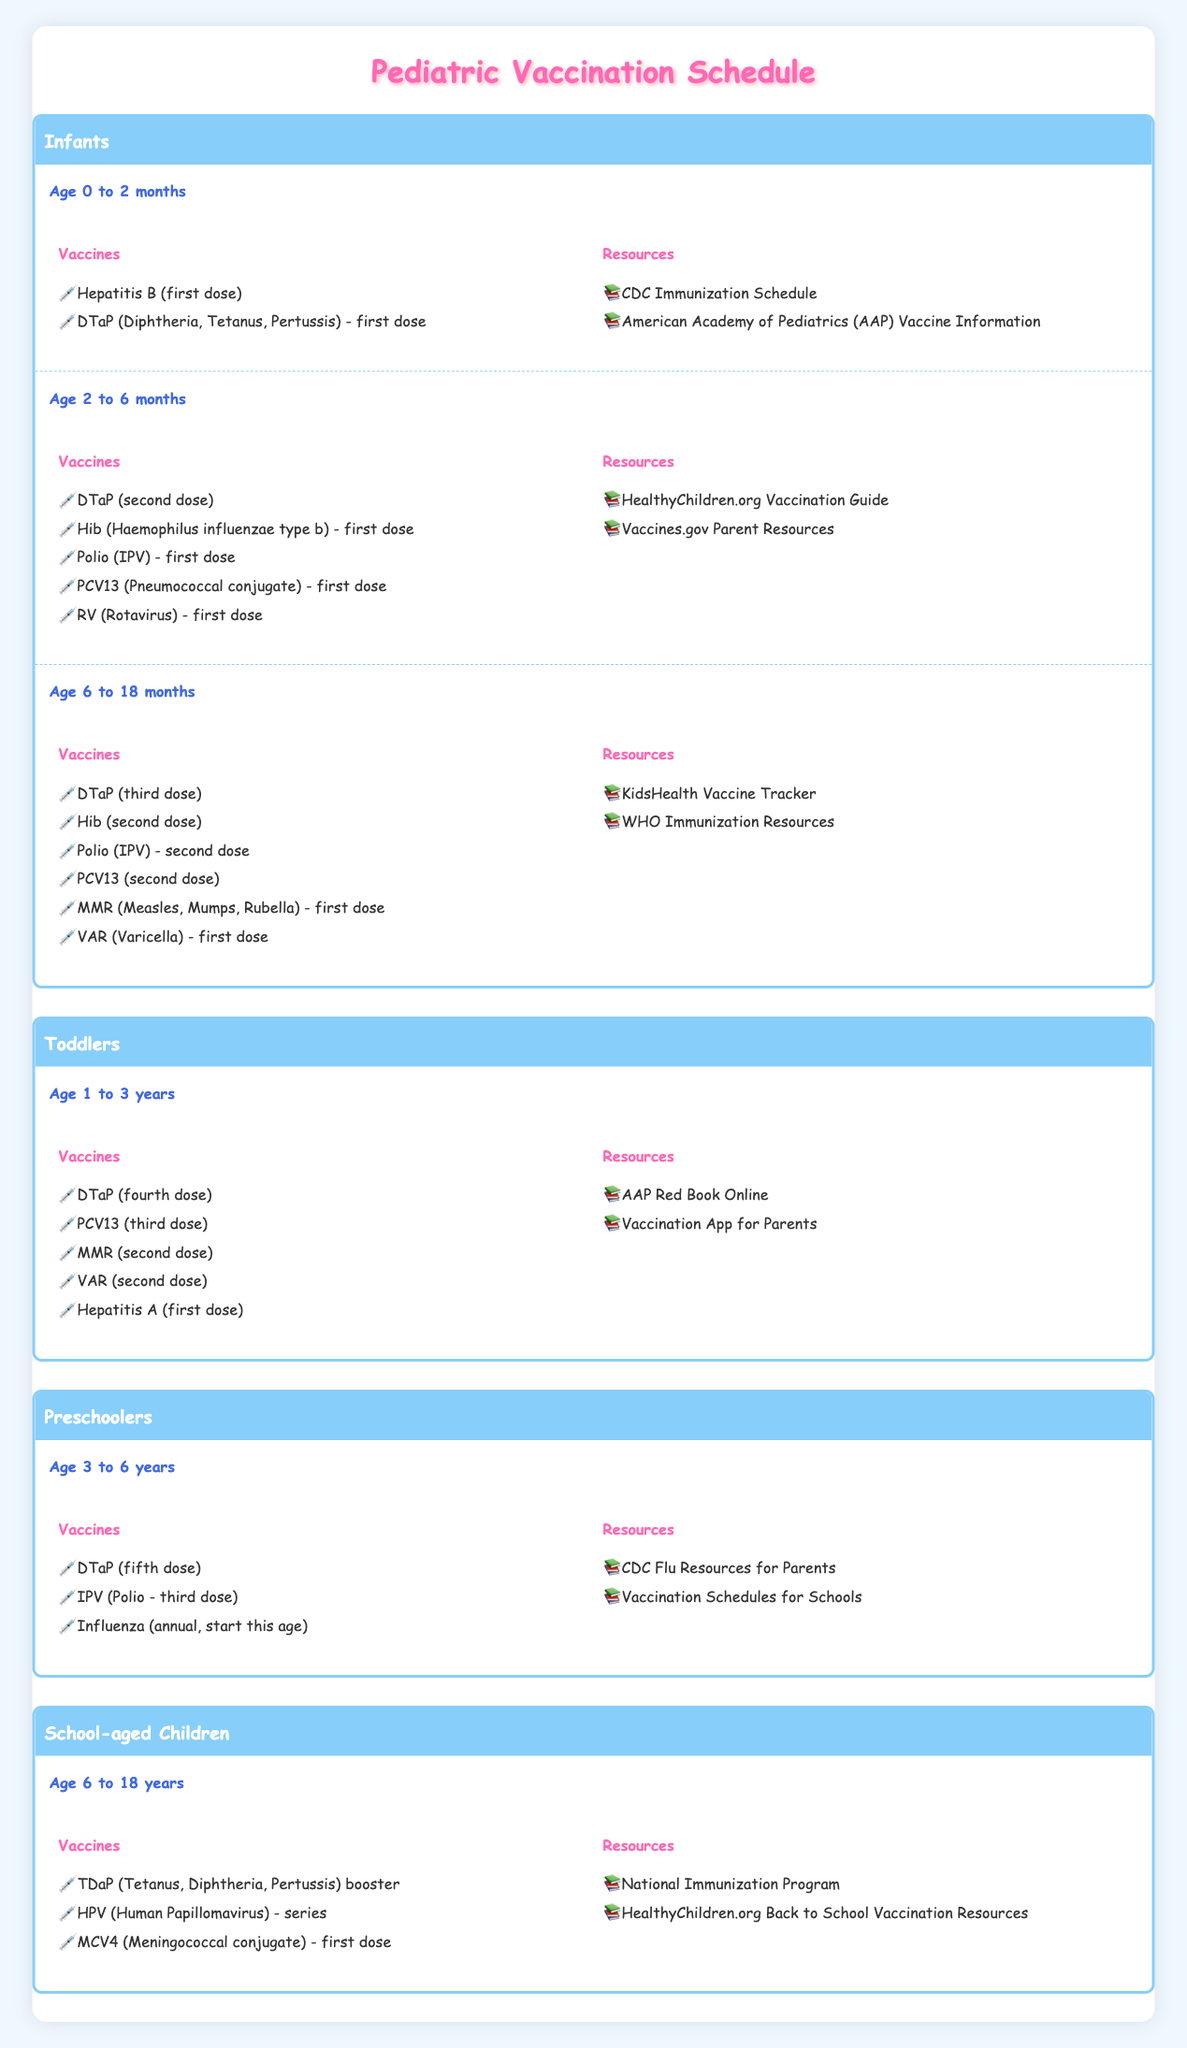What vaccines are given to infants aged 0 to 2 months? According to the table, infants aged 0 to 2 months receive the Hepatitis B (first dose) and DTaP (Diphtheria, Tetanus, Pertussis) - first dose vaccines.
Answer: Hepatitis B (first dose), DTaP (first dose) How many vaccines are provided to toddlers aged 1 to 3 years? In the table, toddlers aged 1 to 3 years receive 5 vaccines: DTaP (fourth dose), PCV13 (third dose), MMR (second dose), VAR (second dose), and Hepatitis A (first dose).
Answer: 5 True or False: Preschoolers receive an influenza vaccine starting at age 3. The table states that preschoolers aged 3 to 6 years receive the influenza vaccine (annual, start this age), thus confirming the statement is true.
Answer: True Which age group is scheduled for the TDaP booster vaccination? The TDaP (Tetanus, Diphtheria, Pertussis) booster is scheduled for school-aged children aged 6 to 18 years, according to the table.
Answer: 6 to 18 years What is the total number of vaccines listed for infants as a whole (0 to 18 months)? For infants across three age segments: 2 vaccines for 0 to 2 months, 5 vaccines for 2 to 6 months, and 6 vaccines for 6 to 18 months. Adding these: 2 + 5 + 6 = 13 vaccines total for infants.
Answer: 13 Which resources are recommended for parents of infants aged 2 to 6 months? The table lists two resources for parents of infants aged 2 to 6 months: HealthyChildren.org Vaccination Guide and Vaccines.gov Parent Resources.
Answer: HealthyChildren.org Vaccination Guide, Vaccines.gov Parent Resources True or False: All children aged 3 years and older receive DTaP vaccines. The table shows that preschoolers receive the DTaP (fifth dose) vaccine at ages 3 to 6 years, but does not indicate that all children aged 3 years and older get DTaP vaccines, therefore the statement is false.
Answer: False How many resources are provided for school-aged children vaccinations? For school-aged children aged 6 to 18 years, two resources are listed in the table: National Immunization Program and HealthyChildren.org Back to School Vaccination Resources. Thus, there are 2 resources.
Answer: 2 